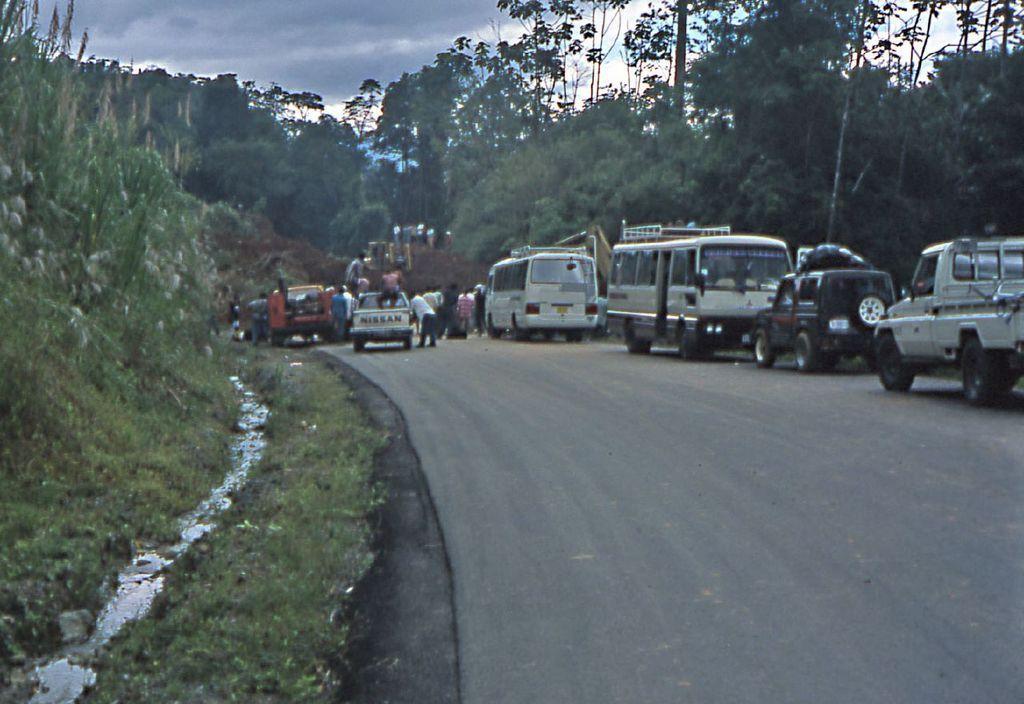In one or two sentences, can you explain what this image depicts? In this image, we can some vehicles on the road. There are some persons in the middle of the image. There are some trees beside the road. There are some plants on the left side of the image. There is a sky at the top of the image. 